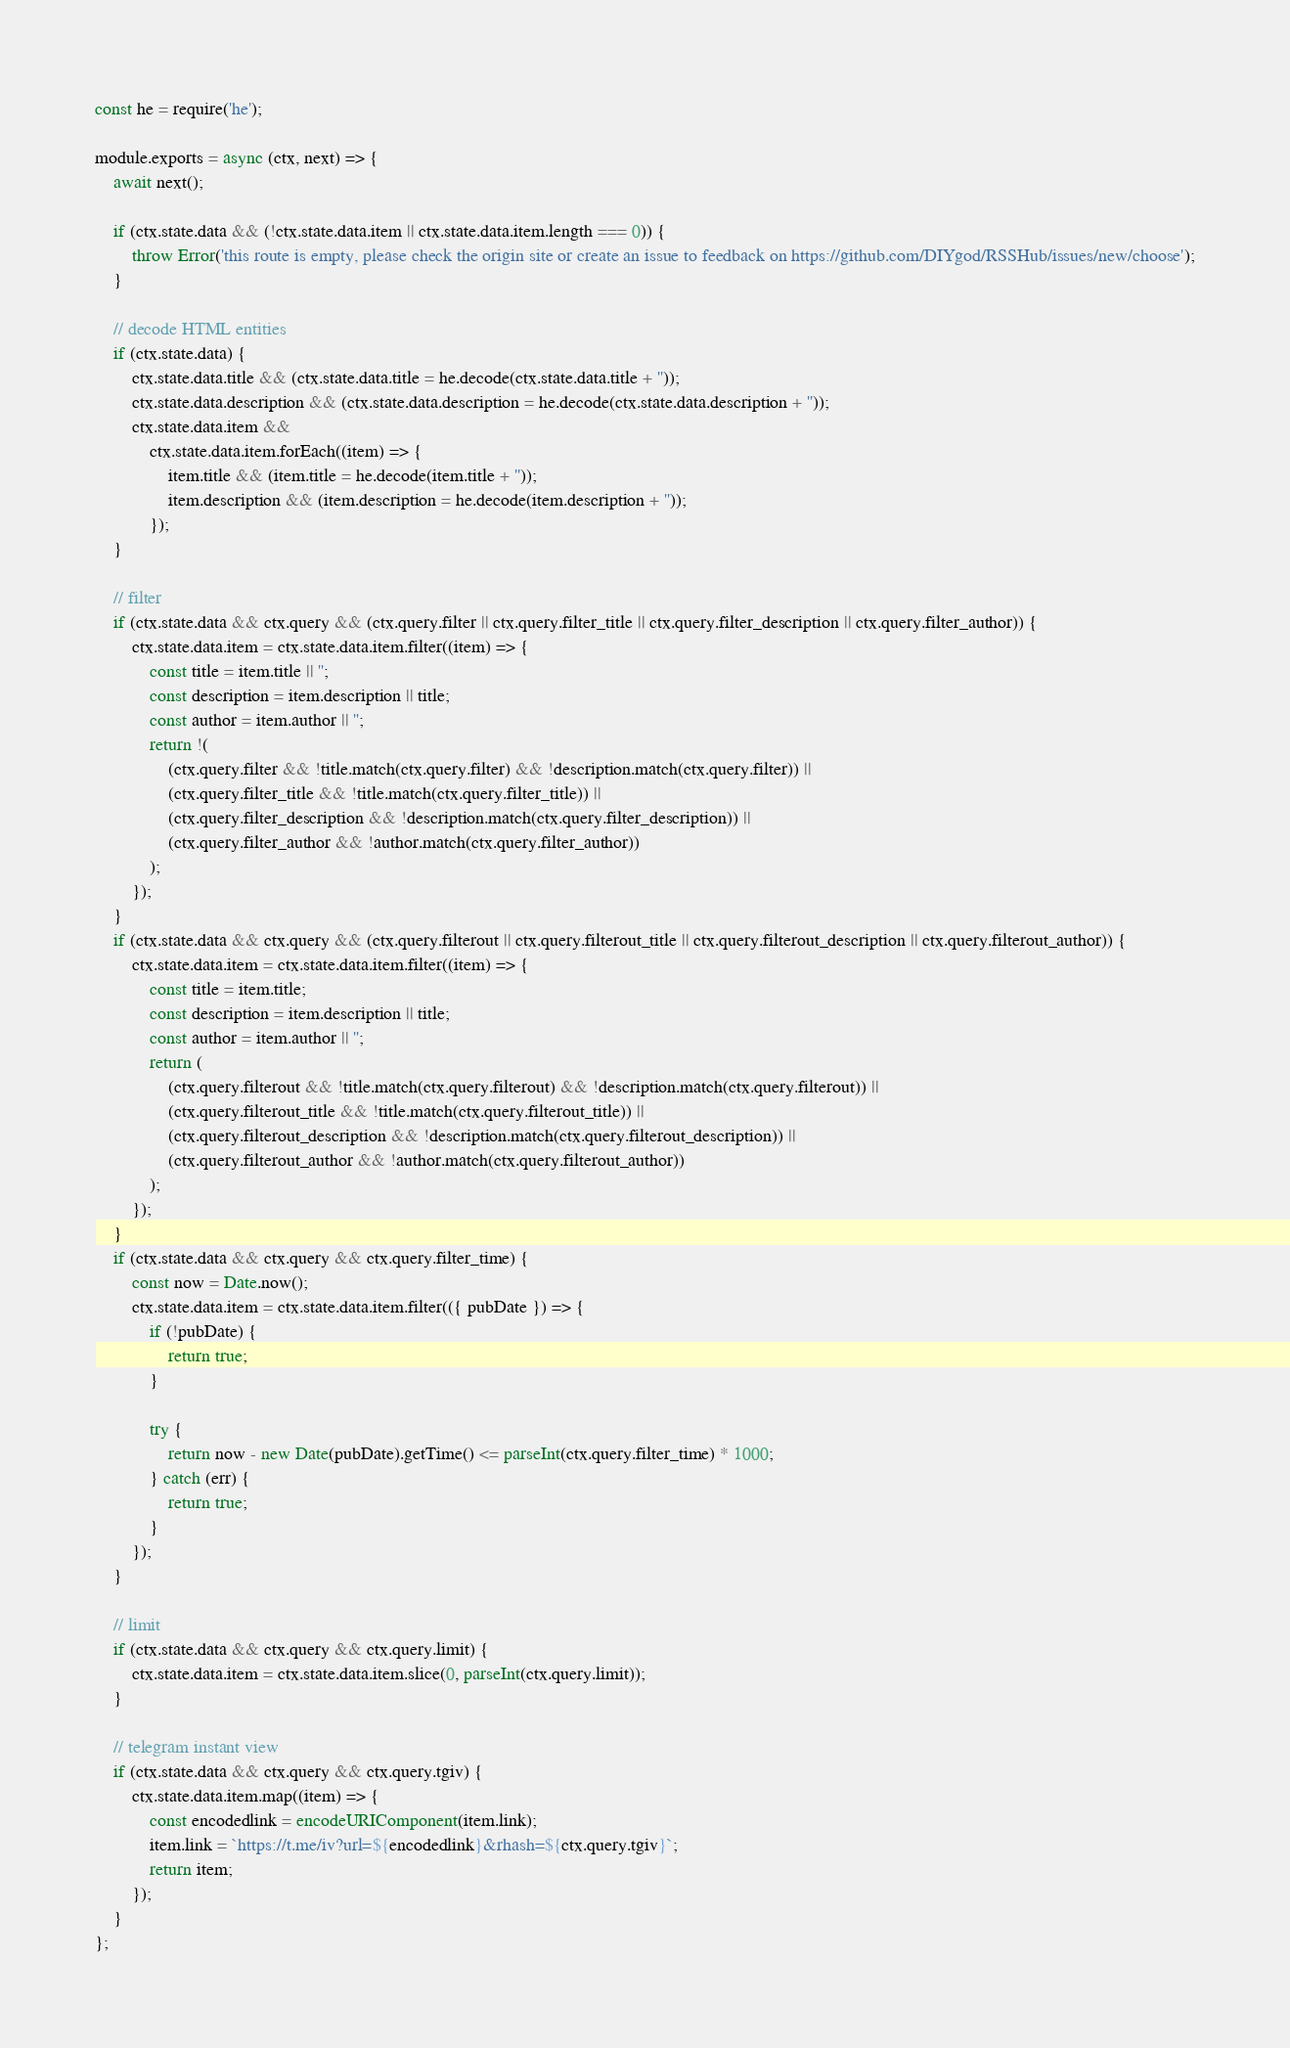<code> <loc_0><loc_0><loc_500><loc_500><_JavaScript_>const he = require('he');

module.exports = async (ctx, next) => {
    await next();

    if (ctx.state.data && (!ctx.state.data.item || ctx.state.data.item.length === 0)) {
        throw Error('this route is empty, please check the origin site or create an issue to feedback on https://github.com/DIYgod/RSSHub/issues/new/choose');
    }

    // decode HTML entities
    if (ctx.state.data) {
        ctx.state.data.title && (ctx.state.data.title = he.decode(ctx.state.data.title + ''));
        ctx.state.data.description && (ctx.state.data.description = he.decode(ctx.state.data.description + ''));
        ctx.state.data.item &&
            ctx.state.data.item.forEach((item) => {
                item.title && (item.title = he.decode(item.title + ''));
                item.description && (item.description = he.decode(item.description + ''));
            });
    }

    // filter
    if (ctx.state.data && ctx.query && (ctx.query.filter || ctx.query.filter_title || ctx.query.filter_description || ctx.query.filter_author)) {
        ctx.state.data.item = ctx.state.data.item.filter((item) => {
            const title = item.title || '';
            const description = item.description || title;
            const author = item.author || '';
            return !(
                (ctx.query.filter && !title.match(ctx.query.filter) && !description.match(ctx.query.filter)) ||
                (ctx.query.filter_title && !title.match(ctx.query.filter_title)) ||
                (ctx.query.filter_description && !description.match(ctx.query.filter_description)) ||
                (ctx.query.filter_author && !author.match(ctx.query.filter_author))
            );
        });
    }
    if (ctx.state.data && ctx.query && (ctx.query.filterout || ctx.query.filterout_title || ctx.query.filterout_description || ctx.query.filterout_author)) {
        ctx.state.data.item = ctx.state.data.item.filter((item) => {
            const title = item.title;
            const description = item.description || title;
            const author = item.author || '';
            return (
                (ctx.query.filterout && !title.match(ctx.query.filterout) && !description.match(ctx.query.filterout)) ||
                (ctx.query.filterout_title && !title.match(ctx.query.filterout_title)) ||
                (ctx.query.filterout_description && !description.match(ctx.query.filterout_description)) ||
                (ctx.query.filterout_author && !author.match(ctx.query.filterout_author))
            );
        });
    }
    if (ctx.state.data && ctx.query && ctx.query.filter_time) {
        const now = Date.now();
        ctx.state.data.item = ctx.state.data.item.filter(({ pubDate }) => {
            if (!pubDate) {
                return true;
            }

            try {
                return now - new Date(pubDate).getTime() <= parseInt(ctx.query.filter_time) * 1000;
            } catch (err) {
                return true;
            }
        });
    }

    // limit
    if (ctx.state.data && ctx.query && ctx.query.limit) {
        ctx.state.data.item = ctx.state.data.item.slice(0, parseInt(ctx.query.limit));
    }

    // telegram instant view
    if (ctx.state.data && ctx.query && ctx.query.tgiv) {
        ctx.state.data.item.map((item) => {
            const encodedlink = encodeURIComponent(item.link);
            item.link = `https://t.me/iv?url=${encodedlink}&rhash=${ctx.query.tgiv}`;
            return item;
        });
    }
};
</code> 